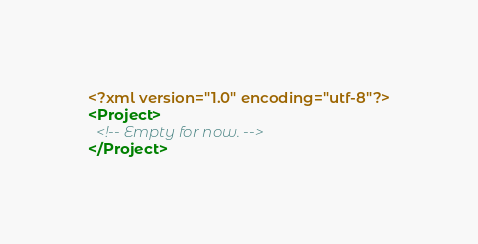Convert code to text. <code><loc_0><loc_0><loc_500><loc_500><_XML_><?xml version="1.0" encoding="utf-8"?>
<Project>
  <!-- Empty for now. -->
</Project>
</code> 